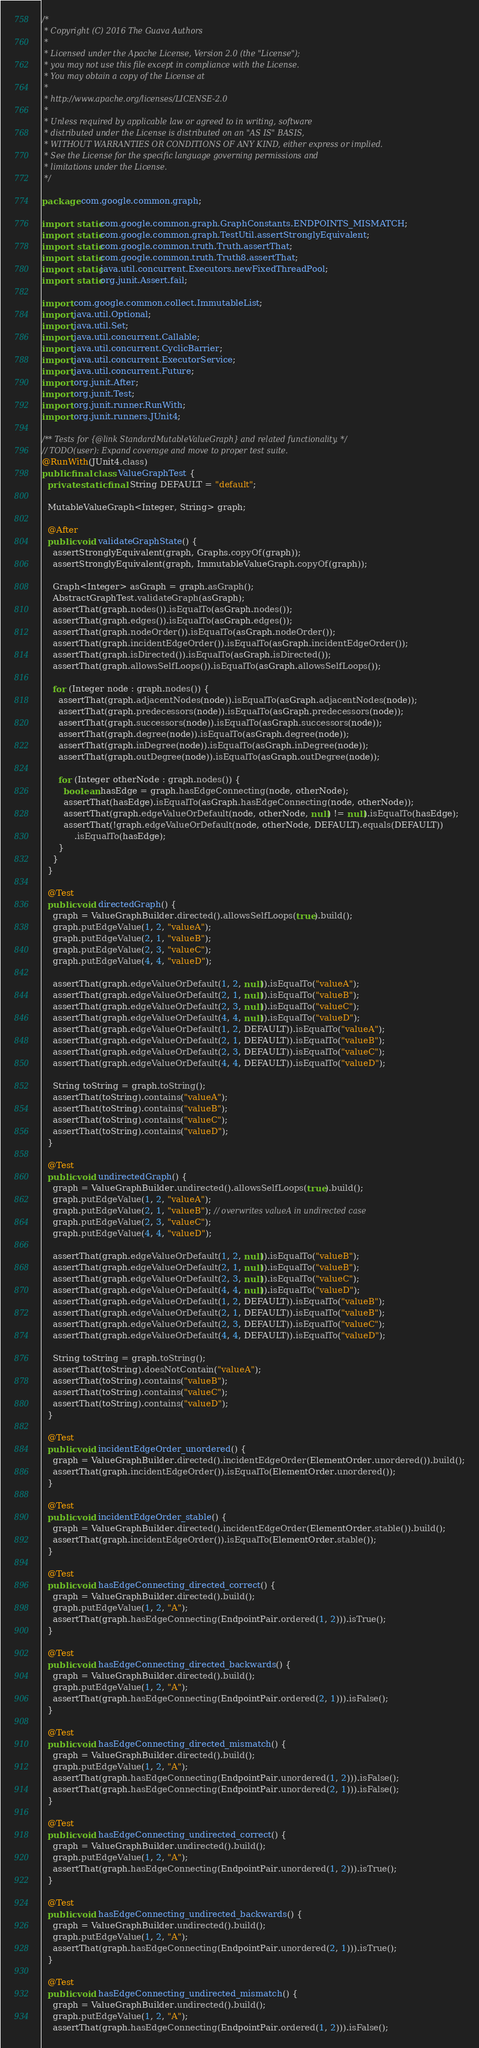<code> <loc_0><loc_0><loc_500><loc_500><_Java_>/*
 * Copyright (C) 2016 The Guava Authors
 *
 * Licensed under the Apache License, Version 2.0 (the "License");
 * you may not use this file except in compliance with the License.
 * You may obtain a copy of the License at
 *
 * http://www.apache.org/licenses/LICENSE-2.0
 *
 * Unless required by applicable law or agreed to in writing, software
 * distributed under the License is distributed on an "AS IS" BASIS,
 * WITHOUT WARRANTIES OR CONDITIONS OF ANY KIND, either express or implied.
 * See the License for the specific language governing permissions and
 * limitations under the License.
 */

package com.google.common.graph;

import static com.google.common.graph.GraphConstants.ENDPOINTS_MISMATCH;
import static com.google.common.graph.TestUtil.assertStronglyEquivalent;
import static com.google.common.truth.Truth.assertThat;
import static com.google.common.truth.Truth8.assertThat;
import static java.util.concurrent.Executors.newFixedThreadPool;
import static org.junit.Assert.fail;

import com.google.common.collect.ImmutableList;
import java.util.Optional;
import java.util.Set;
import java.util.concurrent.Callable;
import java.util.concurrent.CyclicBarrier;
import java.util.concurrent.ExecutorService;
import java.util.concurrent.Future;
import org.junit.After;
import org.junit.Test;
import org.junit.runner.RunWith;
import org.junit.runners.JUnit4;

/** Tests for {@link StandardMutableValueGraph} and related functionality. */
// TODO(user): Expand coverage and move to proper test suite.
@RunWith(JUnit4.class)
public final class ValueGraphTest {
  private static final String DEFAULT = "default";

  MutableValueGraph<Integer, String> graph;

  @After
  public void validateGraphState() {
    assertStronglyEquivalent(graph, Graphs.copyOf(graph));
    assertStronglyEquivalent(graph, ImmutableValueGraph.copyOf(graph));

    Graph<Integer> asGraph = graph.asGraph();
    AbstractGraphTest.validateGraph(asGraph);
    assertThat(graph.nodes()).isEqualTo(asGraph.nodes());
    assertThat(graph.edges()).isEqualTo(asGraph.edges());
    assertThat(graph.nodeOrder()).isEqualTo(asGraph.nodeOrder());
    assertThat(graph.incidentEdgeOrder()).isEqualTo(asGraph.incidentEdgeOrder());
    assertThat(graph.isDirected()).isEqualTo(asGraph.isDirected());
    assertThat(graph.allowsSelfLoops()).isEqualTo(asGraph.allowsSelfLoops());

    for (Integer node : graph.nodes()) {
      assertThat(graph.adjacentNodes(node)).isEqualTo(asGraph.adjacentNodes(node));
      assertThat(graph.predecessors(node)).isEqualTo(asGraph.predecessors(node));
      assertThat(graph.successors(node)).isEqualTo(asGraph.successors(node));
      assertThat(graph.degree(node)).isEqualTo(asGraph.degree(node));
      assertThat(graph.inDegree(node)).isEqualTo(asGraph.inDegree(node));
      assertThat(graph.outDegree(node)).isEqualTo(asGraph.outDegree(node));

      for (Integer otherNode : graph.nodes()) {
        boolean hasEdge = graph.hasEdgeConnecting(node, otherNode);
        assertThat(hasEdge).isEqualTo(asGraph.hasEdgeConnecting(node, otherNode));
        assertThat(graph.edgeValueOrDefault(node, otherNode, null) != null).isEqualTo(hasEdge);
        assertThat(!graph.edgeValueOrDefault(node, otherNode, DEFAULT).equals(DEFAULT))
            .isEqualTo(hasEdge);
      }
    }
  }

  @Test
  public void directedGraph() {
    graph = ValueGraphBuilder.directed().allowsSelfLoops(true).build();
    graph.putEdgeValue(1, 2, "valueA");
    graph.putEdgeValue(2, 1, "valueB");
    graph.putEdgeValue(2, 3, "valueC");
    graph.putEdgeValue(4, 4, "valueD");

    assertThat(graph.edgeValueOrDefault(1, 2, null)).isEqualTo("valueA");
    assertThat(graph.edgeValueOrDefault(2, 1, null)).isEqualTo("valueB");
    assertThat(graph.edgeValueOrDefault(2, 3, null)).isEqualTo("valueC");
    assertThat(graph.edgeValueOrDefault(4, 4, null)).isEqualTo("valueD");
    assertThat(graph.edgeValueOrDefault(1, 2, DEFAULT)).isEqualTo("valueA");
    assertThat(graph.edgeValueOrDefault(2, 1, DEFAULT)).isEqualTo("valueB");
    assertThat(graph.edgeValueOrDefault(2, 3, DEFAULT)).isEqualTo("valueC");
    assertThat(graph.edgeValueOrDefault(4, 4, DEFAULT)).isEqualTo("valueD");

    String toString = graph.toString();
    assertThat(toString).contains("valueA");
    assertThat(toString).contains("valueB");
    assertThat(toString).contains("valueC");
    assertThat(toString).contains("valueD");
  }

  @Test
  public void undirectedGraph() {
    graph = ValueGraphBuilder.undirected().allowsSelfLoops(true).build();
    graph.putEdgeValue(1, 2, "valueA");
    graph.putEdgeValue(2, 1, "valueB"); // overwrites valueA in undirected case
    graph.putEdgeValue(2, 3, "valueC");
    graph.putEdgeValue(4, 4, "valueD");

    assertThat(graph.edgeValueOrDefault(1, 2, null)).isEqualTo("valueB");
    assertThat(graph.edgeValueOrDefault(2, 1, null)).isEqualTo("valueB");
    assertThat(graph.edgeValueOrDefault(2, 3, null)).isEqualTo("valueC");
    assertThat(graph.edgeValueOrDefault(4, 4, null)).isEqualTo("valueD");
    assertThat(graph.edgeValueOrDefault(1, 2, DEFAULT)).isEqualTo("valueB");
    assertThat(graph.edgeValueOrDefault(2, 1, DEFAULT)).isEqualTo("valueB");
    assertThat(graph.edgeValueOrDefault(2, 3, DEFAULT)).isEqualTo("valueC");
    assertThat(graph.edgeValueOrDefault(4, 4, DEFAULT)).isEqualTo("valueD");

    String toString = graph.toString();
    assertThat(toString).doesNotContain("valueA");
    assertThat(toString).contains("valueB");
    assertThat(toString).contains("valueC");
    assertThat(toString).contains("valueD");
  }

  @Test
  public void incidentEdgeOrder_unordered() {
    graph = ValueGraphBuilder.directed().incidentEdgeOrder(ElementOrder.unordered()).build();
    assertThat(graph.incidentEdgeOrder()).isEqualTo(ElementOrder.unordered());
  }

  @Test
  public void incidentEdgeOrder_stable() {
    graph = ValueGraphBuilder.directed().incidentEdgeOrder(ElementOrder.stable()).build();
    assertThat(graph.incidentEdgeOrder()).isEqualTo(ElementOrder.stable());
  }

  @Test
  public void hasEdgeConnecting_directed_correct() {
    graph = ValueGraphBuilder.directed().build();
    graph.putEdgeValue(1, 2, "A");
    assertThat(graph.hasEdgeConnecting(EndpointPair.ordered(1, 2))).isTrue();
  }

  @Test
  public void hasEdgeConnecting_directed_backwards() {
    graph = ValueGraphBuilder.directed().build();
    graph.putEdgeValue(1, 2, "A");
    assertThat(graph.hasEdgeConnecting(EndpointPair.ordered(2, 1))).isFalse();
  }

  @Test
  public void hasEdgeConnecting_directed_mismatch() {
    graph = ValueGraphBuilder.directed().build();
    graph.putEdgeValue(1, 2, "A");
    assertThat(graph.hasEdgeConnecting(EndpointPair.unordered(1, 2))).isFalse();
    assertThat(graph.hasEdgeConnecting(EndpointPair.unordered(2, 1))).isFalse();
  }

  @Test
  public void hasEdgeConnecting_undirected_correct() {
    graph = ValueGraphBuilder.undirected().build();
    graph.putEdgeValue(1, 2, "A");
    assertThat(graph.hasEdgeConnecting(EndpointPair.unordered(1, 2))).isTrue();
  }

  @Test
  public void hasEdgeConnecting_undirected_backwards() {
    graph = ValueGraphBuilder.undirected().build();
    graph.putEdgeValue(1, 2, "A");
    assertThat(graph.hasEdgeConnecting(EndpointPair.unordered(2, 1))).isTrue();
  }

  @Test
  public void hasEdgeConnecting_undirected_mismatch() {
    graph = ValueGraphBuilder.undirected().build();
    graph.putEdgeValue(1, 2, "A");
    assertThat(graph.hasEdgeConnecting(EndpointPair.ordered(1, 2))).isFalse();</code> 